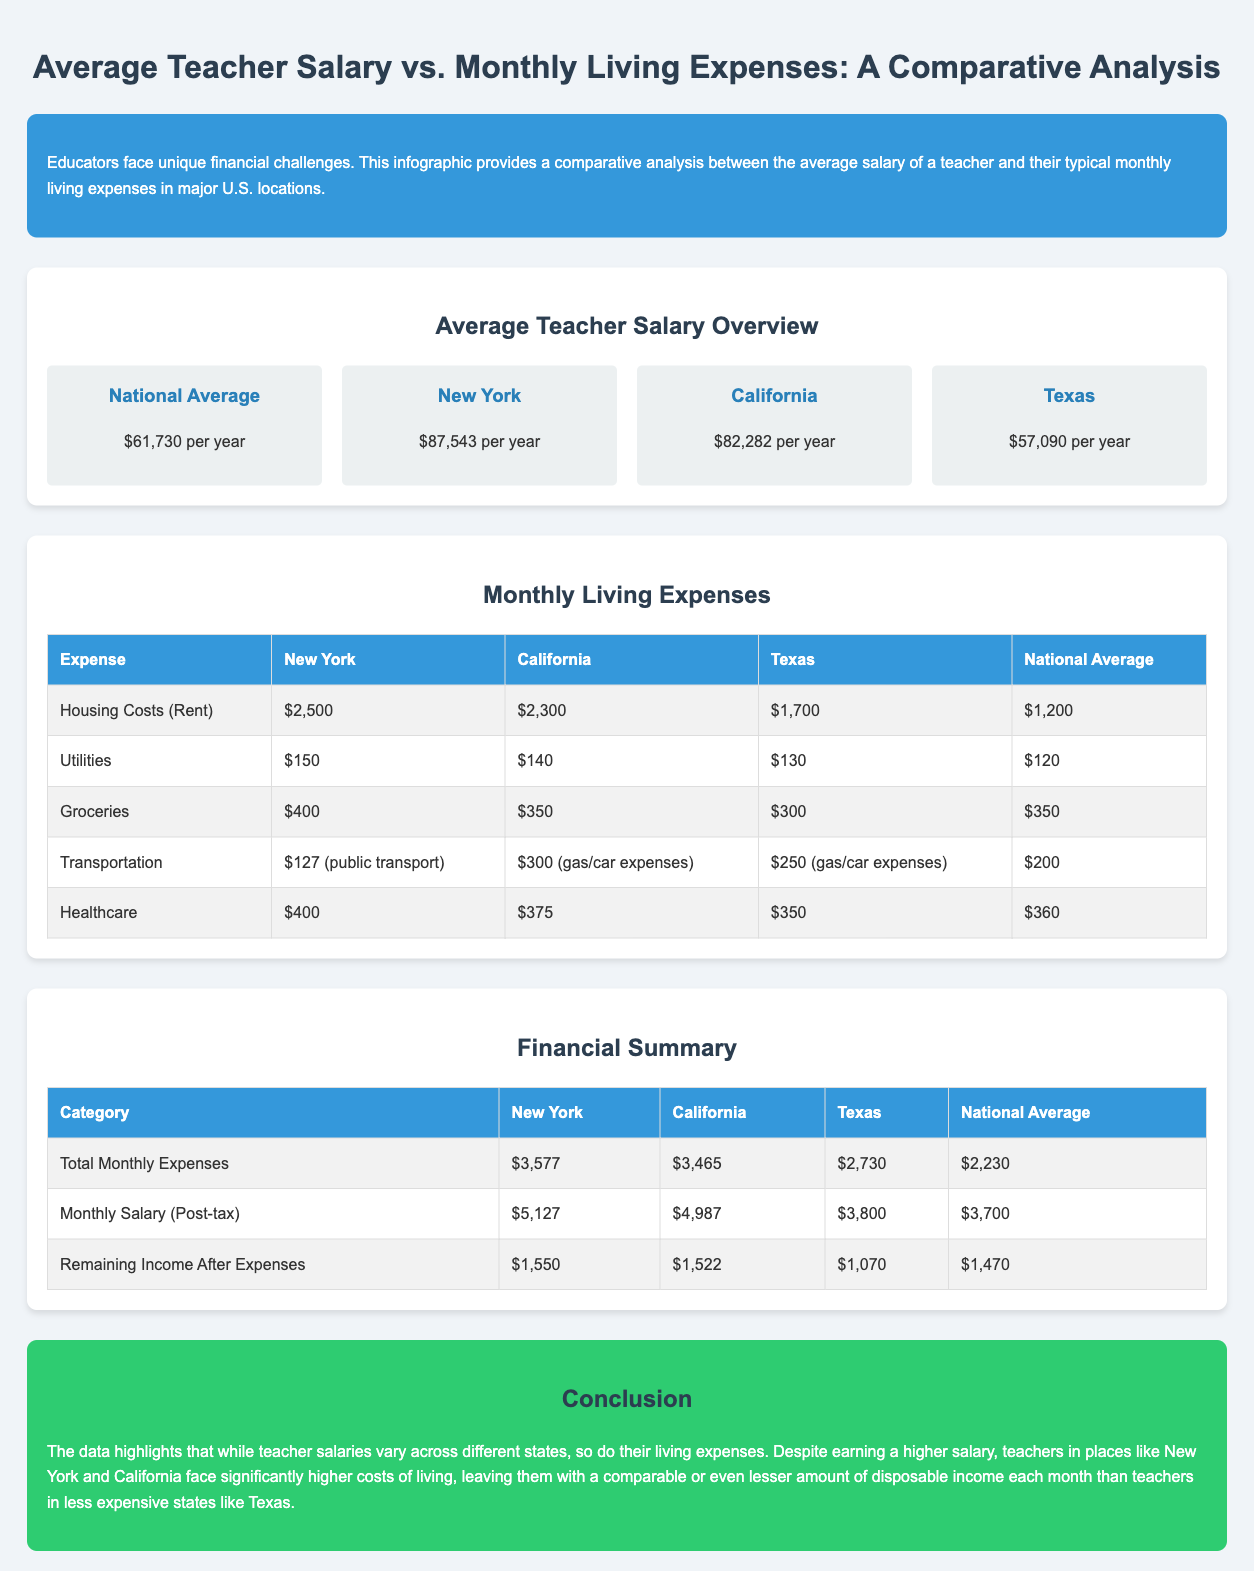What is the national average teacher salary? The national average teacher salary is stated in the document as $61,730 per year.
Answer: $61,730 per year What are the housing costs in New York? The document lists housing costs (rent) in New York as $2,500.
Answer: $2,500 What is the total monthly expense for teachers in Texas? The total monthly expenses for teachers in Texas is presented in the financial summary as $2,730.
Answer: $2,730 How much remaining income do teachers in California have after expenses? The information in the financial summary shows that teachers in California have $1,522 remaining after expenses.
Answer: $1,522 Which state has the highest monthly salary (post-tax)? The document states that New York has the highest monthly salary post-tax at $5,127.
Answer: $5,127 What is the total for groceries in the National Average? The groceries expense in the National Average is listed as $350.
Answer: $350 How do the living expenses of New York compare to Texas? To answer this, one can note that living expenses in New York are significantly higher at $3,577 compared to Texas at $2,730.
Answer: Higher What conclusion can be drawn about disposable income for teachers in expensive states? The conclusion in the document suggests that despite higher salaries, disposable income may be lower due to higher living costs.
Answer: Lower What expense category has the least amount in California? According to the expenses table, the category with the least amount in California is utilities at $140.
Answer: Utilities What percentage of their salary do teachers in Texas have as remaining income? Calculating remaining income relative to their salary gives insight into their financial situation. Teachers in Texas have $1,070 remaining after expenses based on their monthly post-tax salary.
Answer: $1,070 